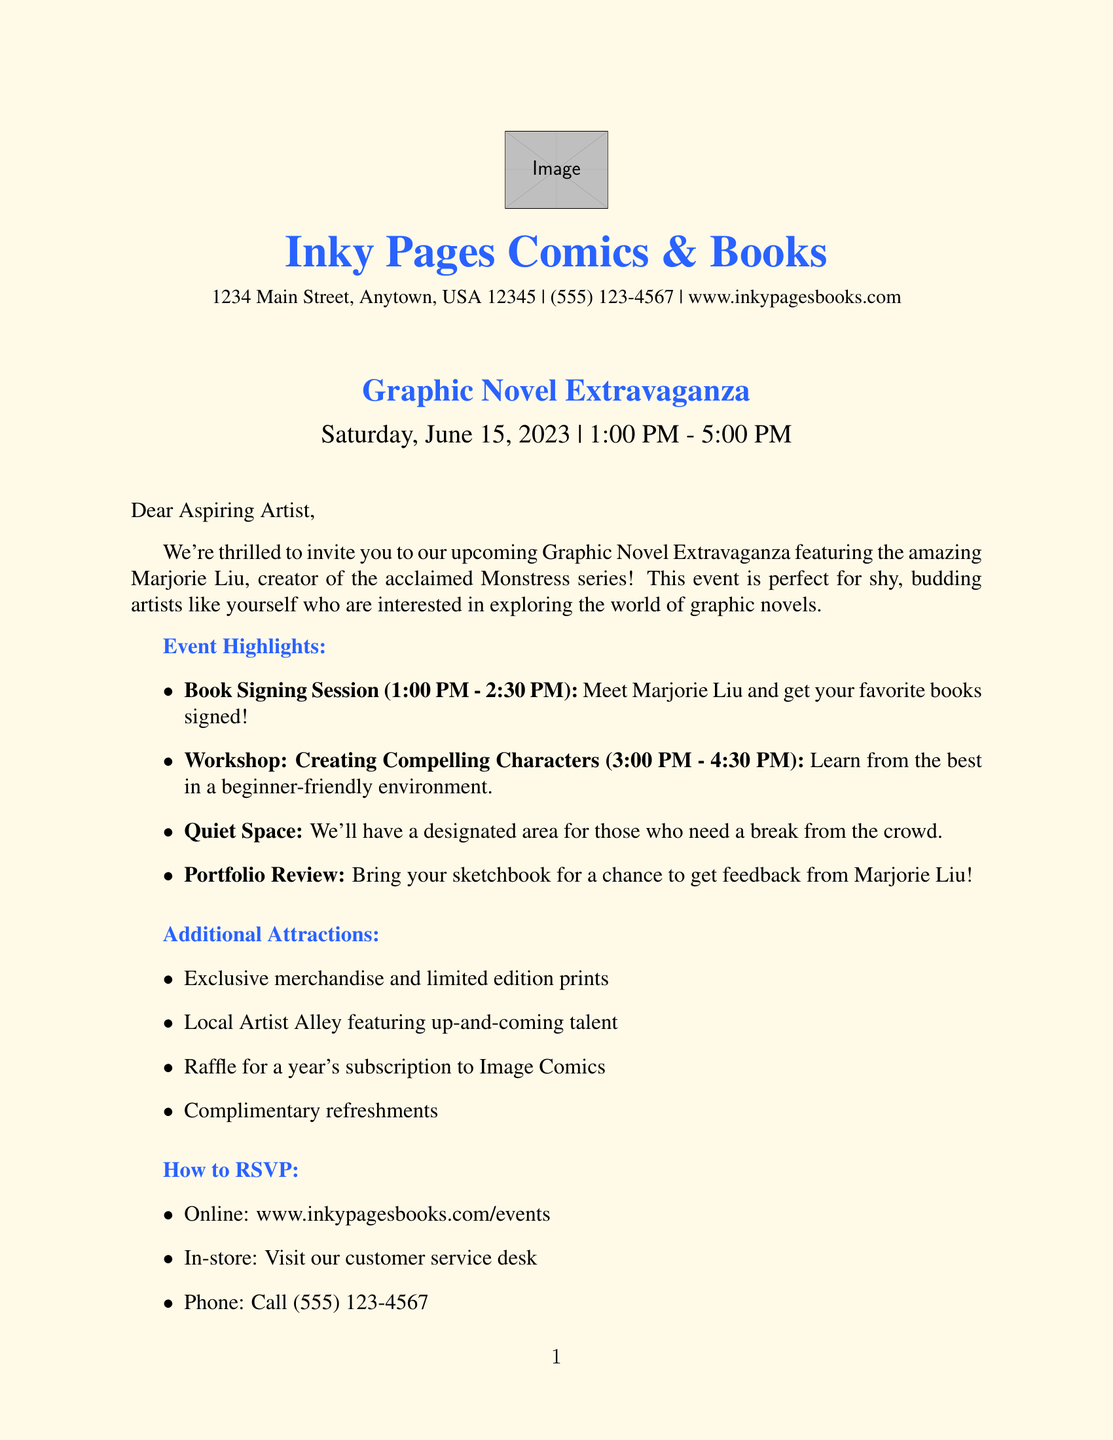What is the name of the bookstore? The bookstore's name is mentioned at the beginning of the document.
Answer: Inky Pages Comics & Books Who is the featured artist at the event? The document specifies the featured artist who will be present at the signing.
Answer: Marjorie Liu What date is the Graphic Novel Extravaganza? The event date is clearly stated in the event details section of the document.
Answer: Saturday, June 15, 2023 What is the workshop titled? The title of the workshop is listed under the workshop details.
Answer: Creating Compelling Characters in Graphic Novels How long does the signing session last? The duration of the signing session is mentioned in the signing session section.
Answer: 1:00 PM - 2:30 PM What is the fee for the workshop? The document mentions the cost required to participate in the workshop.
Answer: $15 Is registration required for the workshop? The document indicates whether participants need to register ahead of time.
Answer: Yes What materials are provided in the workshop? The materials included in the workshop are listed in the workshop details.
Answer: Sketchpads, Pencils, Character design worksheets What is offered for those who need a break from the crowd? The document highlights a specific area for attendees needing a quiet space.
Answer: Designated quiet space What is one of the additional attractions at the event? The document lists various attractions available at the event beyond the main activities.
Answer: Limited edition prints and signed copies available for purchase 